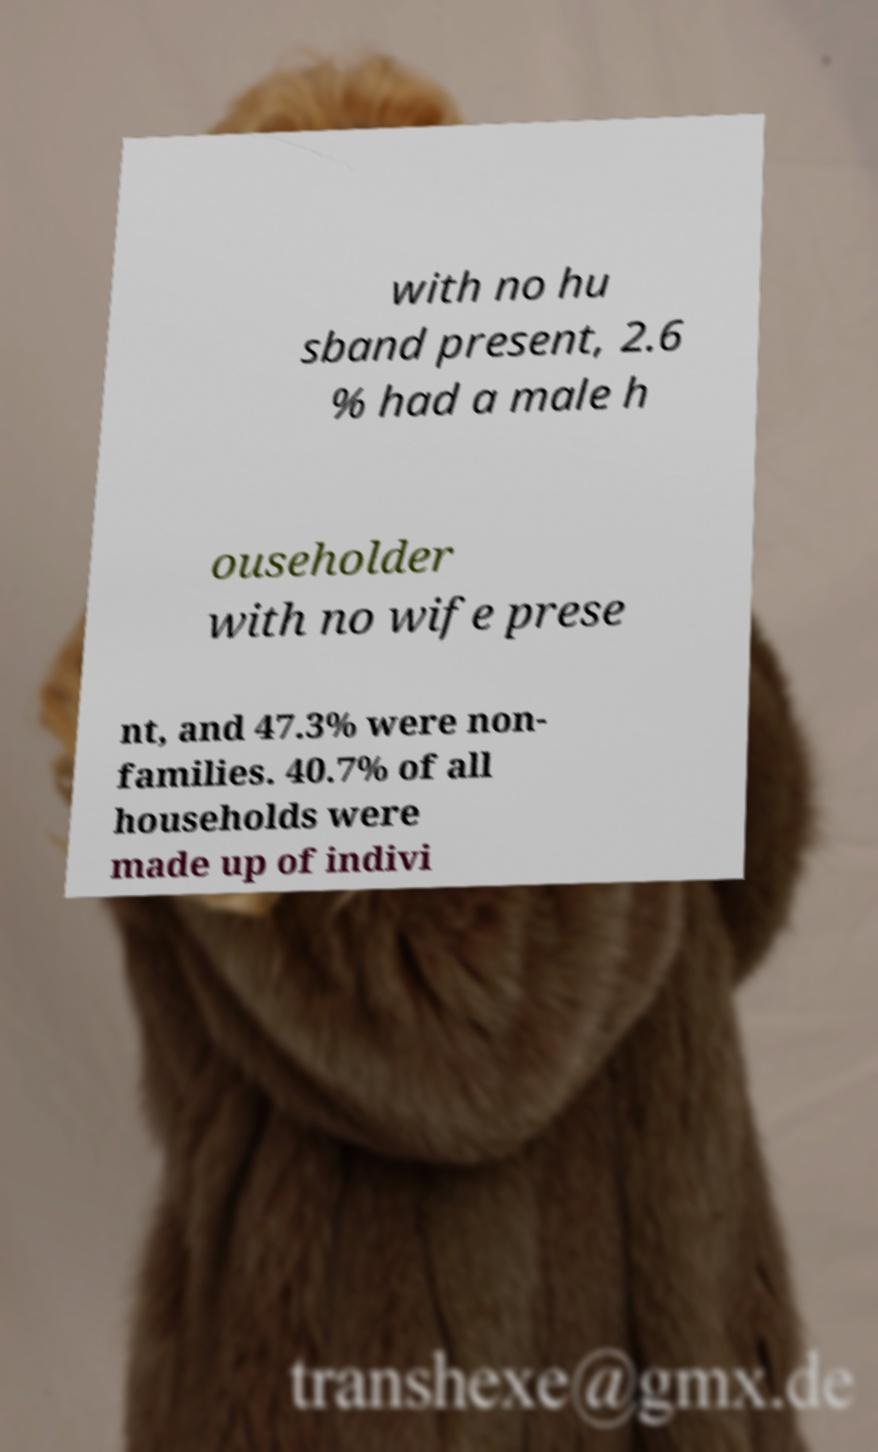Could you extract and type out the text from this image? with no hu sband present, 2.6 % had a male h ouseholder with no wife prese nt, and 47.3% were non- families. 40.7% of all households were made up of indivi 